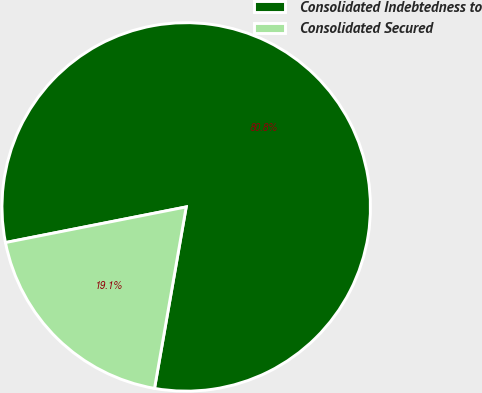Convert chart to OTSL. <chart><loc_0><loc_0><loc_500><loc_500><pie_chart><fcel>Consolidated Indebtedness to<fcel>Consolidated Secured<nl><fcel>80.85%<fcel>19.15%<nl></chart> 